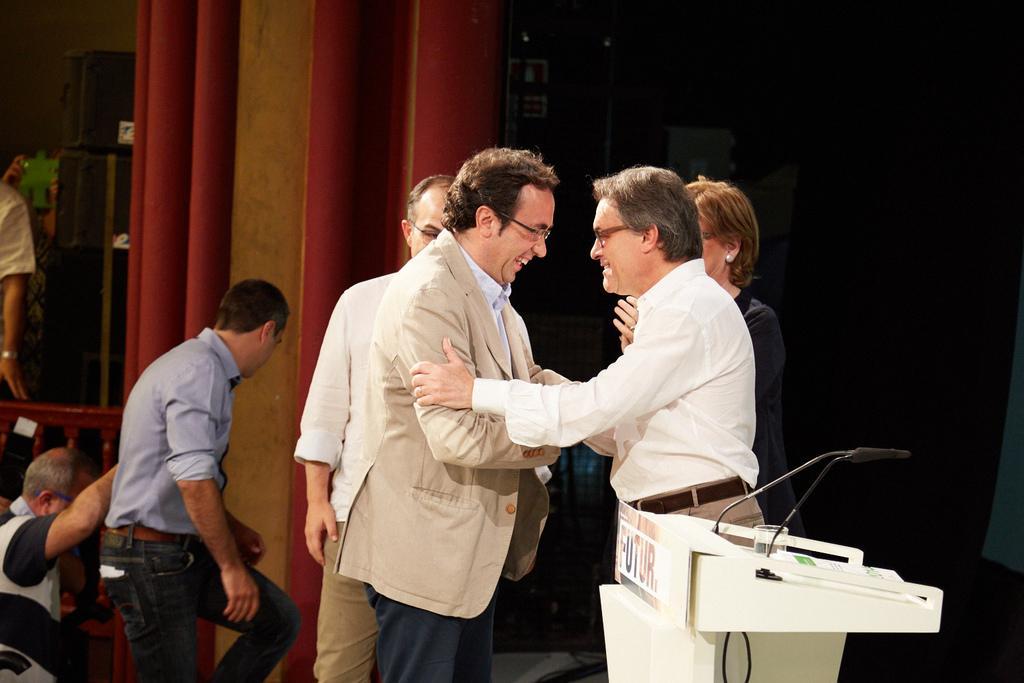Describe this image in one or two sentences. There are many people in this image. Few are wearing specs. Also there is a podium with mics, glass and paper. On the podium there is a board with something written. In the back there is a red color object. Also there are boxes. And there is a wooden railing. 